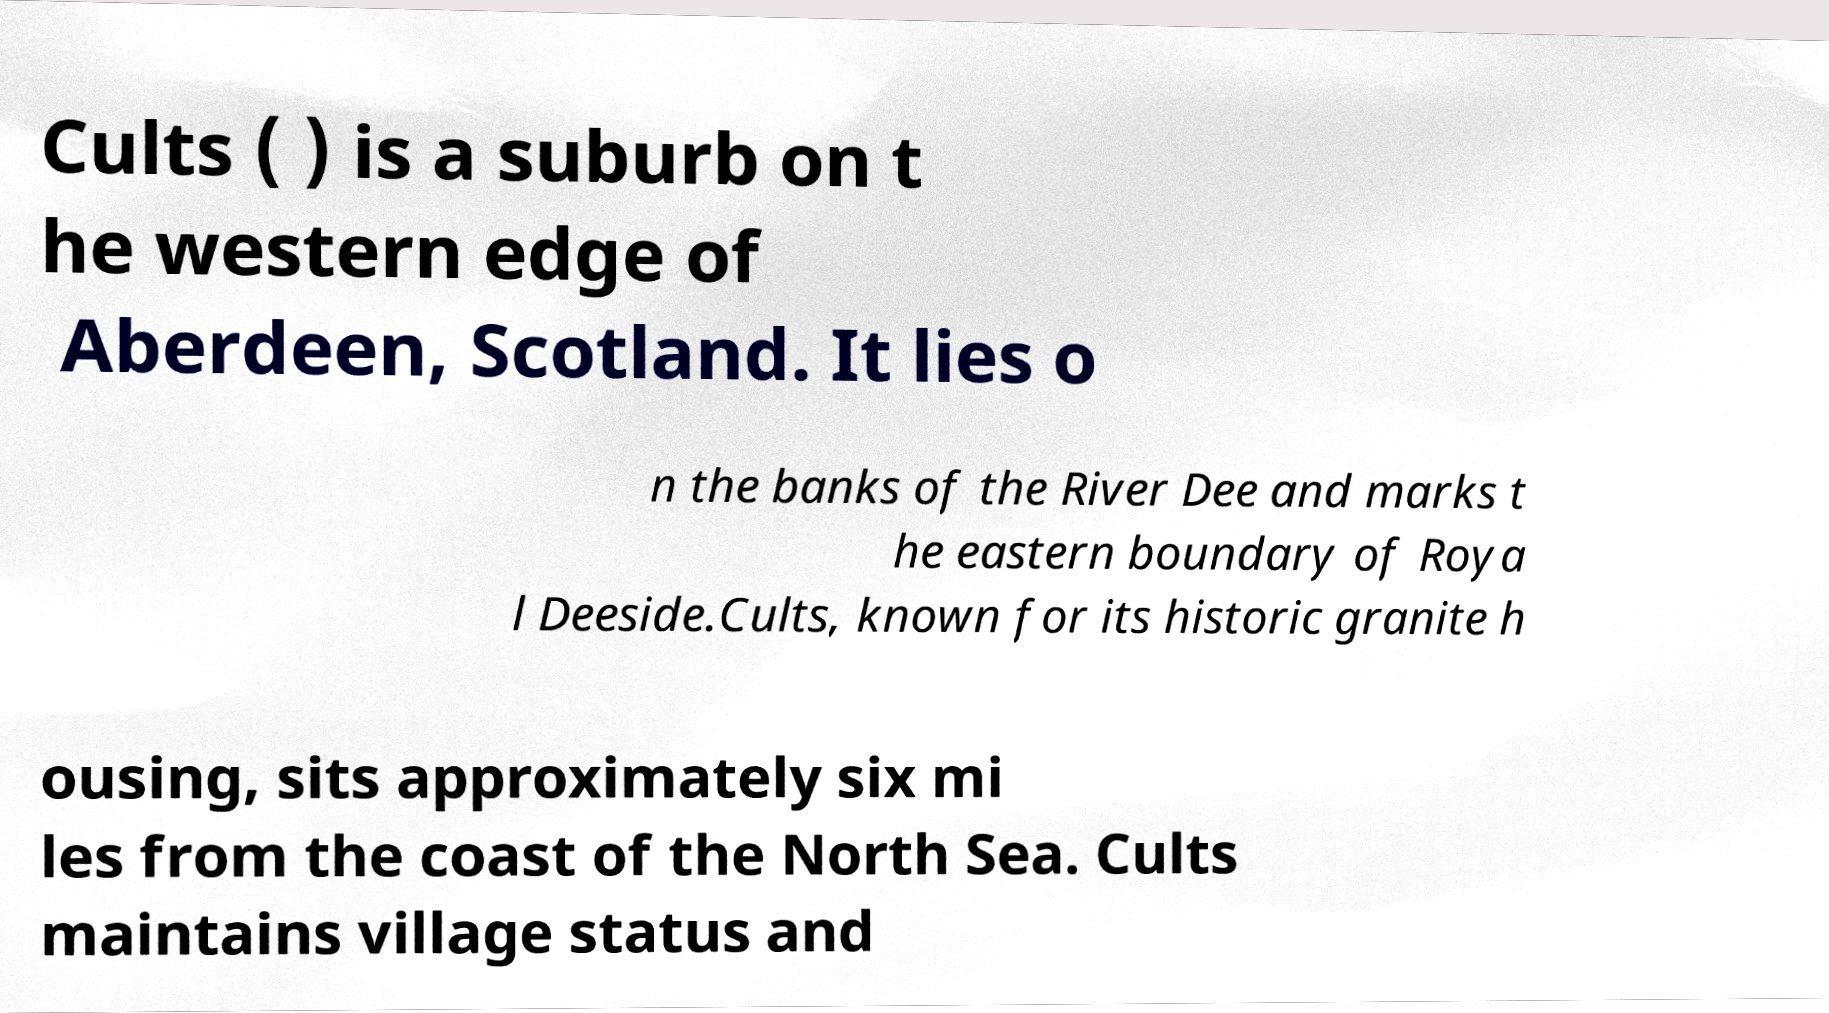Can you read and provide the text displayed in the image?This photo seems to have some interesting text. Can you extract and type it out for me? Cults ( ) is a suburb on t he western edge of Aberdeen, Scotland. It lies o n the banks of the River Dee and marks t he eastern boundary of Roya l Deeside.Cults, known for its historic granite h ousing, sits approximately six mi les from the coast of the North Sea. Cults maintains village status and 